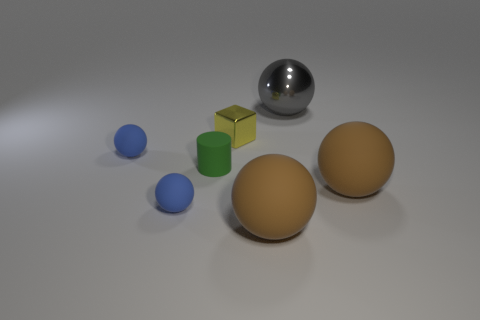Is there anything else that is the same color as the tiny metallic object?
Offer a terse response. No. There is a tiny matte cylinder; is its color the same as the metal thing that is to the right of the yellow metallic object?
Provide a short and direct response. No. What number of other objects are there of the same size as the yellow shiny object?
Give a very brief answer. 3. What number of cylinders are either tiny green matte objects or metal things?
Make the answer very short. 1. There is a blue object behind the cylinder; is its shape the same as the yellow shiny object?
Keep it short and to the point. No. Is the number of big matte spheres that are right of the large gray ball greater than the number of small spheres?
Offer a terse response. No. What is the color of the other shiny thing that is the same size as the green thing?
Offer a very short reply. Yellow. How many things are either balls that are to the right of the block or blue things?
Your answer should be compact. 5. What is the material of the big brown thing that is behind the big brown matte ball that is left of the large gray object?
Ensure brevity in your answer.  Rubber. Are there any other small green objects that have the same material as the small green thing?
Your answer should be compact. No. 